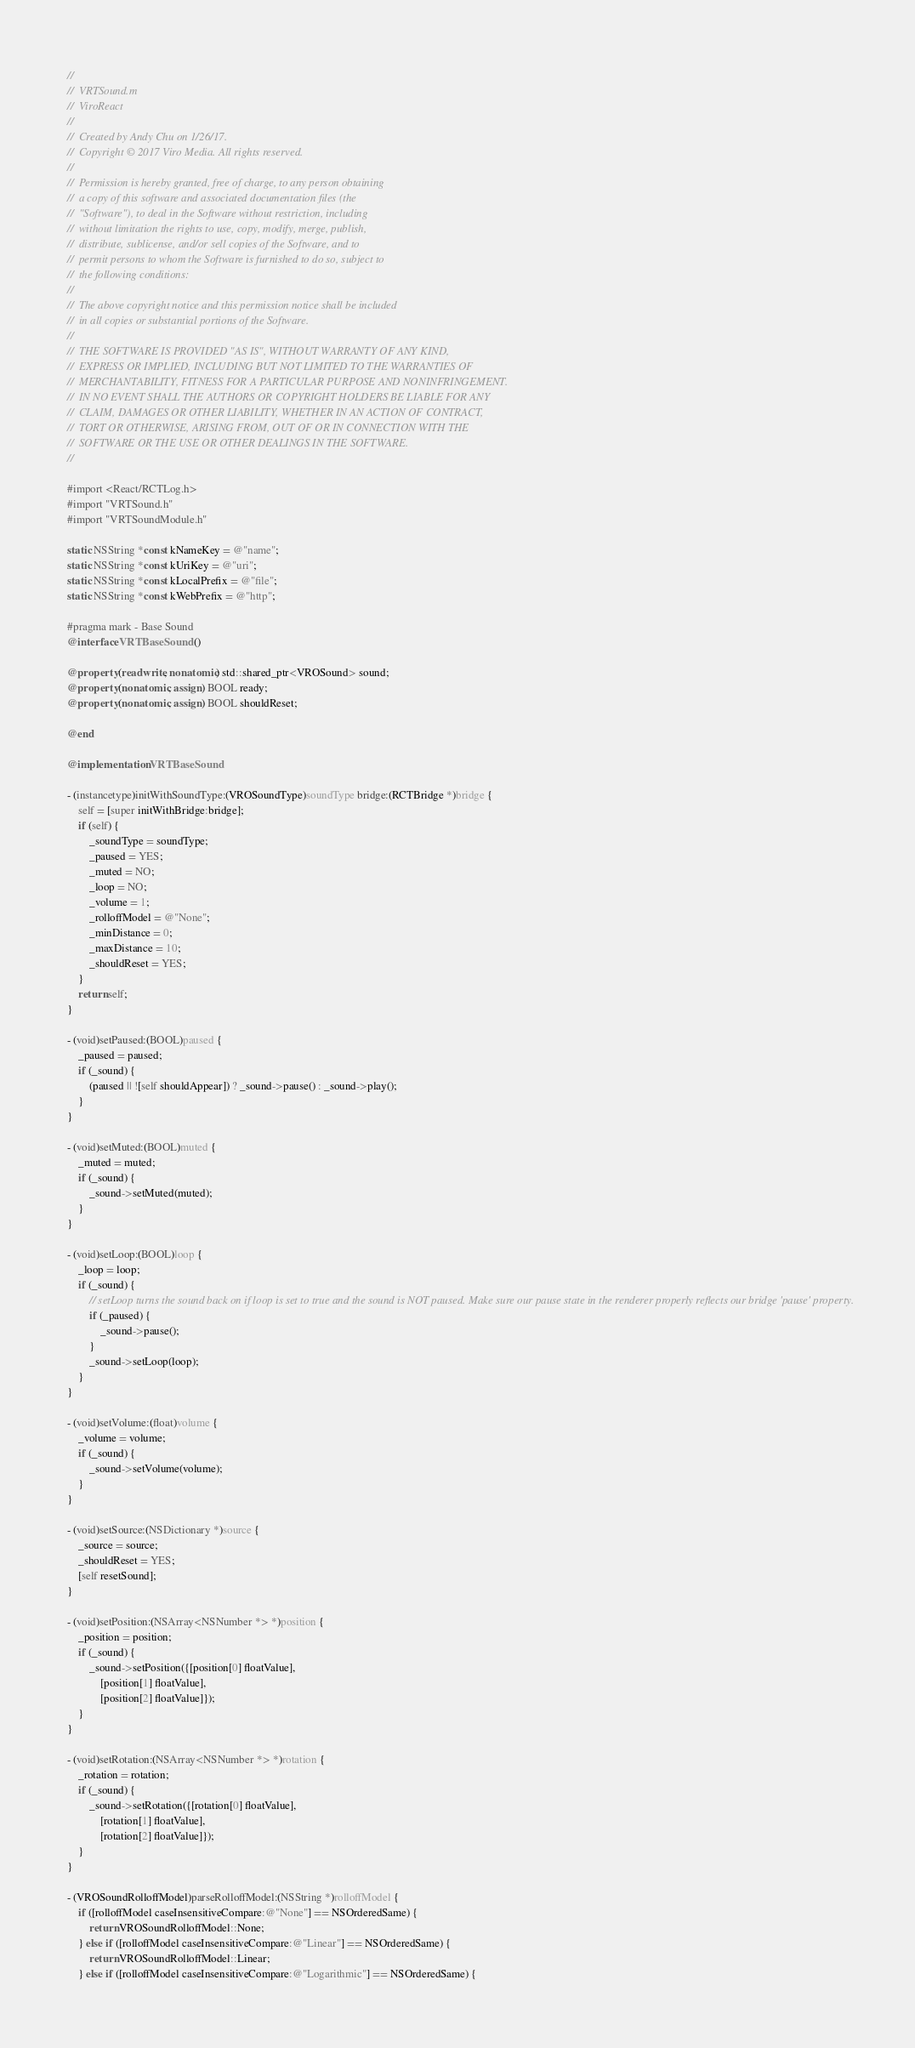<code> <loc_0><loc_0><loc_500><loc_500><_ObjectiveC_>//
//  VRTSound.m
//  ViroReact
//
//  Created by Andy Chu on 1/26/17.
//  Copyright © 2017 Viro Media. All rights reserved.
//
//  Permission is hereby granted, free of charge, to any person obtaining
//  a copy of this software and associated documentation files (the
//  "Software"), to deal in the Software without restriction, including
//  without limitation the rights to use, copy, modify, merge, publish,
//  distribute, sublicense, and/or sell copies of the Software, and to
//  permit persons to whom the Software is furnished to do so, subject to
//  the following conditions:
//
//  The above copyright notice and this permission notice shall be included
//  in all copies or substantial portions of the Software.
//
//  THE SOFTWARE IS PROVIDED "AS IS", WITHOUT WARRANTY OF ANY KIND,
//  EXPRESS OR IMPLIED, INCLUDING BUT NOT LIMITED TO THE WARRANTIES OF
//  MERCHANTABILITY, FITNESS FOR A PARTICULAR PURPOSE AND NONINFRINGEMENT.
//  IN NO EVENT SHALL THE AUTHORS OR COPYRIGHT HOLDERS BE LIABLE FOR ANY
//  CLAIM, DAMAGES OR OTHER LIABILITY, WHETHER IN AN ACTION OF CONTRACT,
//  TORT OR OTHERWISE, ARISING FROM, OUT OF OR IN CONNECTION WITH THE
//  SOFTWARE OR THE USE OR OTHER DEALINGS IN THE SOFTWARE.
//

#import <React/RCTLog.h>
#import "VRTSound.h"
#import "VRTSoundModule.h"

static NSString *const kNameKey = @"name";
static NSString *const kUriKey = @"uri";
static NSString *const kLocalPrefix = @"file";
static NSString *const kWebPrefix = @"http";

#pragma mark - Base Sound
@interface VRTBaseSound ()

@property (readwrite, nonatomic) std::shared_ptr<VROSound> sound;
@property (nonatomic, assign) BOOL ready;
@property (nonatomic, assign) BOOL shouldReset;

@end

@implementation VRTBaseSound

- (instancetype)initWithSoundType:(VROSoundType)soundType bridge:(RCTBridge *)bridge {
    self = [super initWithBridge:bridge];
    if (self) {
        _soundType = soundType;
        _paused = YES;
        _muted = NO;
        _loop = NO;
        _volume = 1;
        _rolloffModel = @"None";
        _minDistance = 0;
        _maxDistance = 10;
        _shouldReset = YES;
    }
    return self;
}

- (void)setPaused:(BOOL)paused {
    _paused = paused;
    if (_sound) {
        (paused || ![self shouldAppear]) ? _sound->pause() : _sound->play();
    }
}

- (void)setMuted:(BOOL)muted {
    _muted = muted;
    if (_sound) {
        _sound->setMuted(muted);
    }
}

- (void)setLoop:(BOOL)loop {
    _loop = loop;
    if (_sound) {
        // setLoop turns the sound back on if loop is set to true and the sound is NOT paused. Make sure our pause state in the renderer properly reflects our bridge 'pause' property.
        if (_paused) {
            _sound->pause();
        }
        _sound->setLoop(loop);
    }
}

- (void)setVolume:(float)volume {
    _volume = volume;
    if (_sound) {
        _sound->setVolume(volume);
    }
}

- (void)setSource:(NSDictionary *)source {
    _source = source;
    _shouldReset = YES;
    [self resetSound];
}

- (void)setPosition:(NSArray<NSNumber *> *)position {
    _position = position;
    if (_sound) {
        _sound->setPosition({[position[0] floatValue],
            [position[1] floatValue],
            [position[2] floatValue]});
    }
}

- (void)setRotation:(NSArray<NSNumber *> *)rotation {
    _rotation = rotation;
    if (_sound) {
        _sound->setRotation({[rotation[0] floatValue],
            [rotation[1] floatValue],
            [rotation[2] floatValue]});
    }
}

- (VROSoundRolloffModel)parseRolloffModel:(NSString *)rolloffModel {
    if ([rolloffModel caseInsensitiveCompare:@"None"] == NSOrderedSame) {
        return VROSoundRolloffModel::None;
    } else if ([rolloffModel caseInsensitiveCompare:@"Linear"] == NSOrderedSame) {
        return VROSoundRolloffModel::Linear;
    } else if ([rolloffModel caseInsensitiveCompare:@"Logarithmic"] == NSOrderedSame) {</code> 